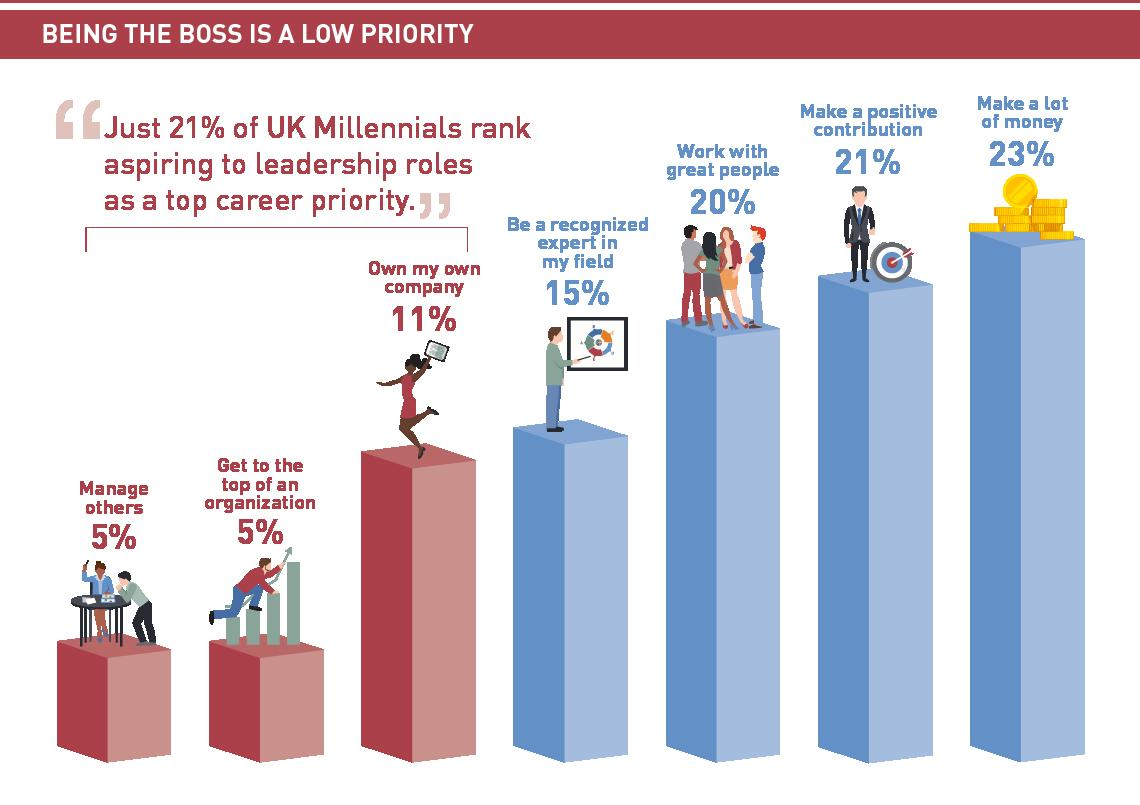Mention a couple of crucial points in this snapshot. According to a recent survey, only 10% of the population aspires to manage others or reach the top of a company. According to the data, a combined 44% of people want to either make money or make a positive contribution. 